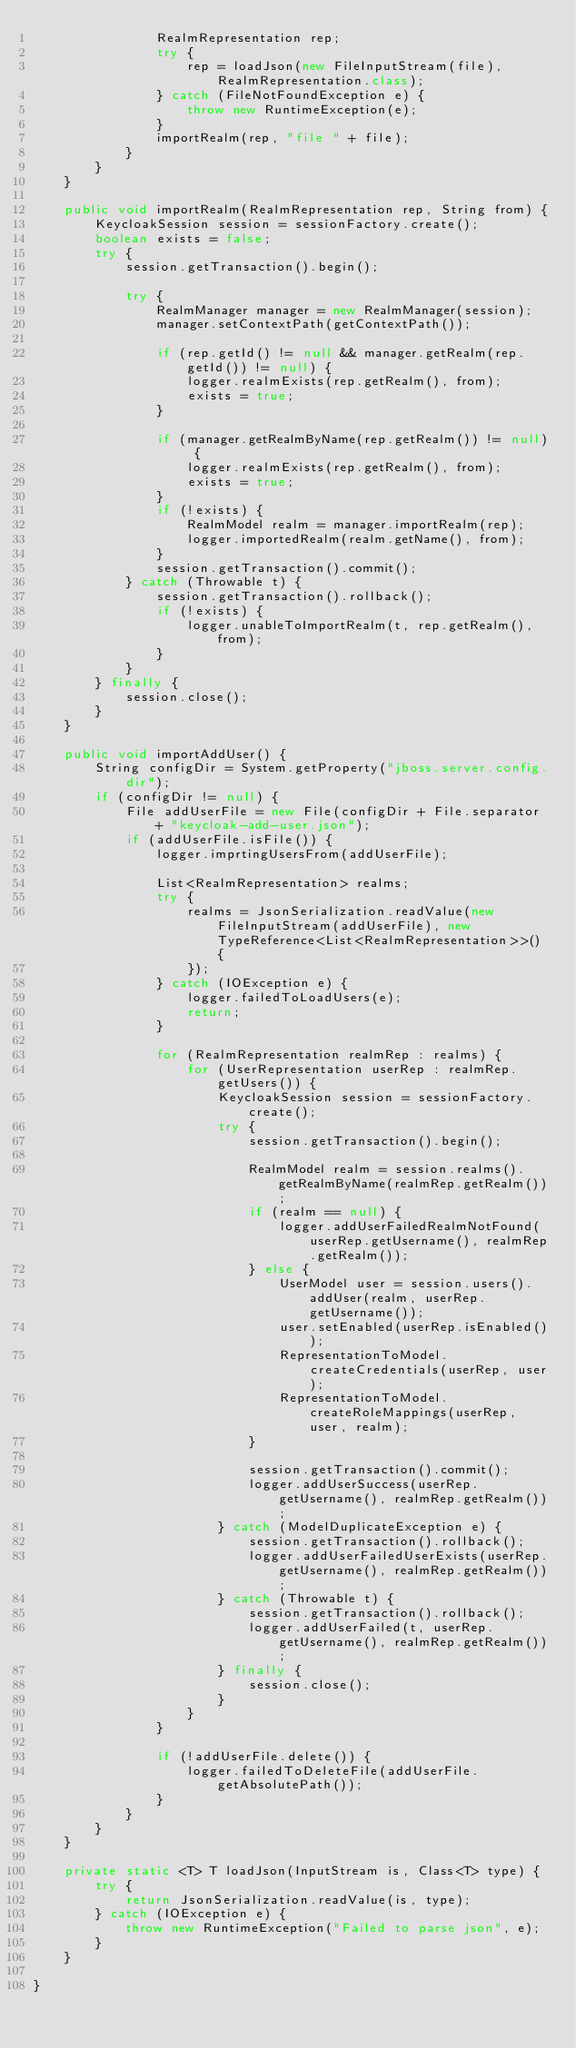Convert code to text. <code><loc_0><loc_0><loc_500><loc_500><_Java_>                RealmRepresentation rep;
                try {
                    rep = loadJson(new FileInputStream(file), RealmRepresentation.class);
                } catch (FileNotFoundException e) {
                    throw new RuntimeException(e);
                }
                importRealm(rep, "file " + file);
            }
        }
    }

    public void importRealm(RealmRepresentation rep, String from) {
        KeycloakSession session = sessionFactory.create();
        boolean exists = false;
        try {
            session.getTransaction().begin();

            try {
                RealmManager manager = new RealmManager(session);
                manager.setContextPath(getContextPath());

                if (rep.getId() != null && manager.getRealm(rep.getId()) != null) {
                    logger.realmExists(rep.getRealm(), from);
                    exists = true;
                }

                if (manager.getRealmByName(rep.getRealm()) != null) {
                    logger.realmExists(rep.getRealm(), from);
                    exists = true;
                }
                if (!exists) {
                    RealmModel realm = manager.importRealm(rep);
                    logger.importedRealm(realm.getName(), from);
                }
                session.getTransaction().commit();
            } catch (Throwable t) {
                session.getTransaction().rollback();
                if (!exists) {
                    logger.unableToImportRealm(t, rep.getRealm(), from);
                }
            }
        } finally {
            session.close();
        }
    }

    public void importAddUser() {
        String configDir = System.getProperty("jboss.server.config.dir");
        if (configDir != null) {
            File addUserFile = new File(configDir + File.separator + "keycloak-add-user.json");
            if (addUserFile.isFile()) {
                logger.imprtingUsersFrom(addUserFile);

                List<RealmRepresentation> realms;
                try {
                    realms = JsonSerialization.readValue(new FileInputStream(addUserFile), new TypeReference<List<RealmRepresentation>>() {
                    });
                } catch (IOException e) {
                    logger.failedToLoadUsers(e);
                    return;
                }

                for (RealmRepresentation realmRep : realms) {
                    for (UserRepresentation userRep : realmRep.getUsers()) {
                        KeycloakSession session = sessionFactory.create();
                        try {
                            session.getTransaction().begin();

                            RealmModel realm = session.realms().getRealmByName(realmRep.getRealm());
                            if (realm == null) {
                                logger.addUserFailedRealmNotFound(userRep.getUsername(), realmRep.getRealm());
                            } else {
                                UserModel user = session.users().addUser(realm, userRep.getUsername());
                                user.setEnabled(userRep.isEnabled());
                                RepresentationToModel.createCredentials(userRep, user);
                                RepresentationToModel.createRoleMappings(userRep, user, realm);
                            }

                            session.getTransaction().commit();
                            logger.addUserSuccess(userRep.getUsername(), realmRep.getRealm());
                        } catch (ModelDuplicateException e) {
                            session.getTransaction().rollback();
                            logger.addUserFailedUserExists(userRep.getUsername(), realmRep.getRealm());
                        } catch (Throwable t) {
                            session.getTransaction().rollback();
                            logger.addUserFailed(t, userRep.getUsername(), realmRep.getRealm());
                        } finally {
                            session.close();
                        }
                    }
                }

                if (!addUserFile.delete()) {
                    logger.failedToDeleteFile(addUserFile.getAbsolutePath());
                }
            }
        }
    }

    private static <T> T loadJson(InputStream is, Class<T> type) {
        try {
            return JsonSerialization.readValue(is, type);
        } catch (IOException e) {
            throw new RuntimeException("Failed to parse json", e);
        }
    }

}
</code> 